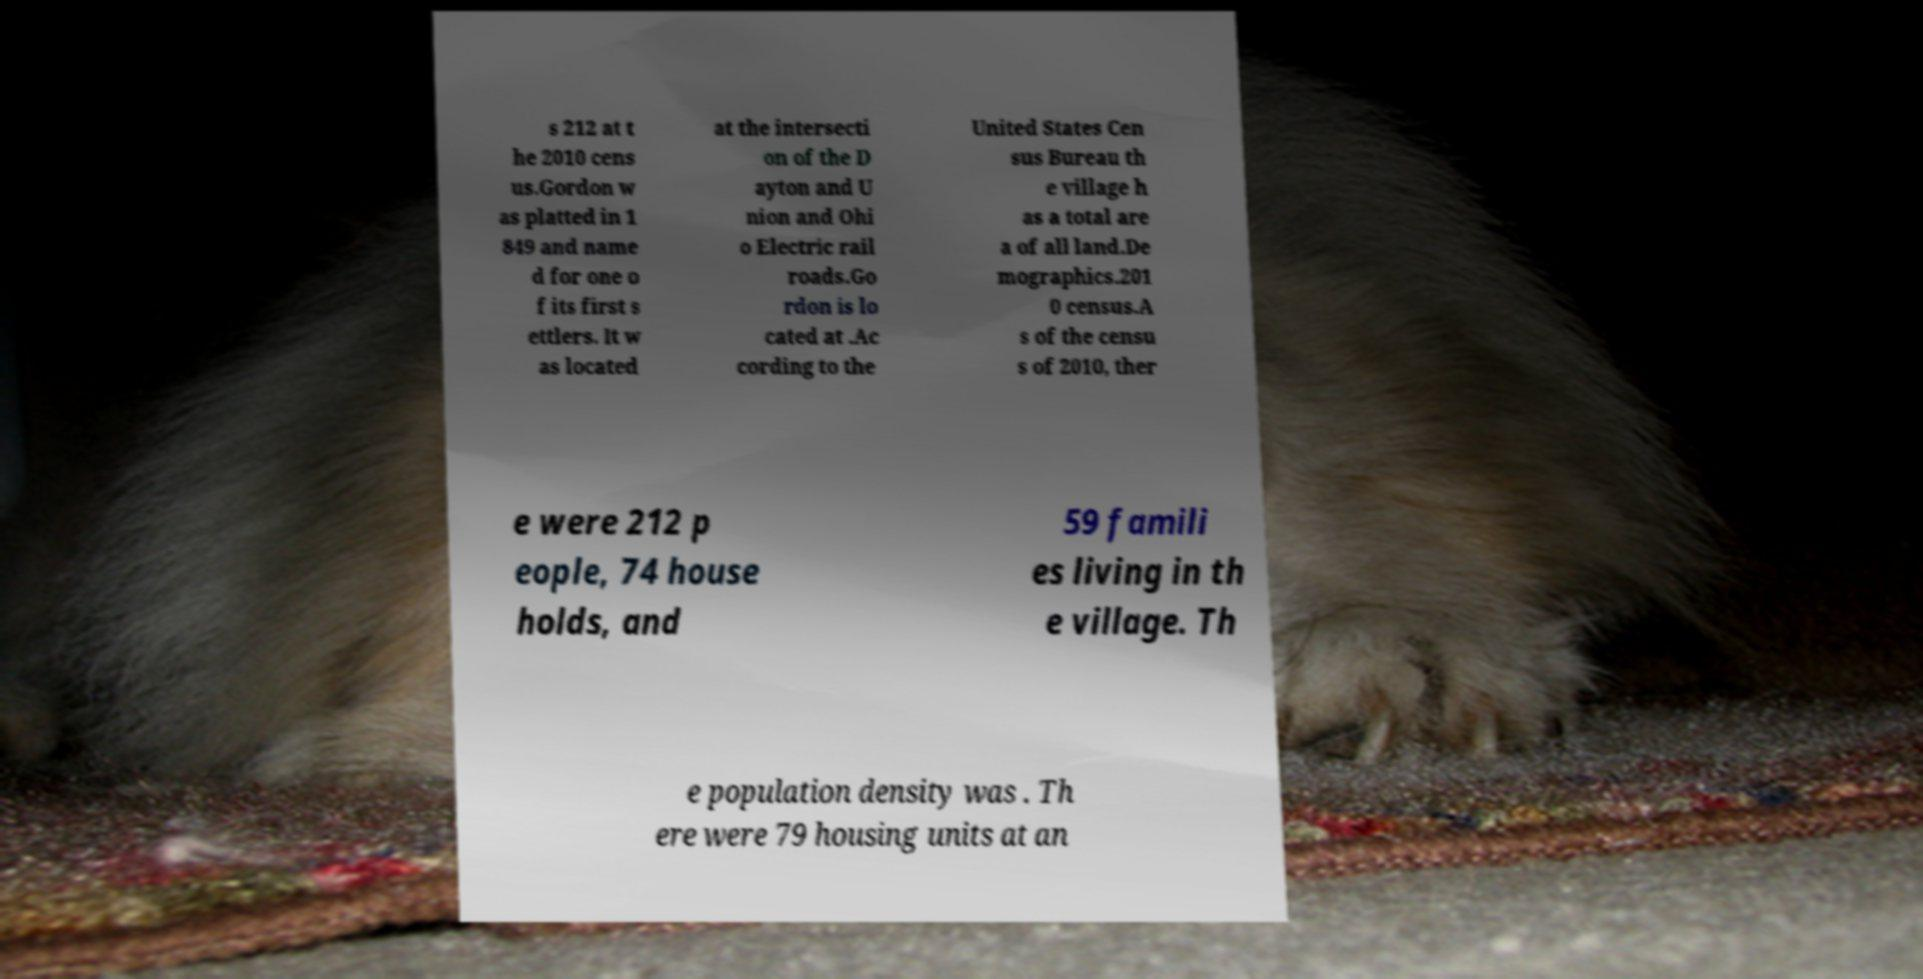Please identify and transcribe the text found in this image. s 212 at t he 2010 cens us.Gordon w as platted in 1 849 and name d for one o f its first s ettlers. It w as located at the intersecti on of the D ayton and U nion and Ohi o Electric rail roads.Go rdon is lo cated at .Ac cording to the United States Cen sus Bureau th e village h as a total are a of all land.De mographics.201 0 census.A s of the censu s of 2010, ther e were 212 p eople, 74 house holds, and 59 famili es living in th e village. Th e population density was . Th ere were 79 housing units at an 